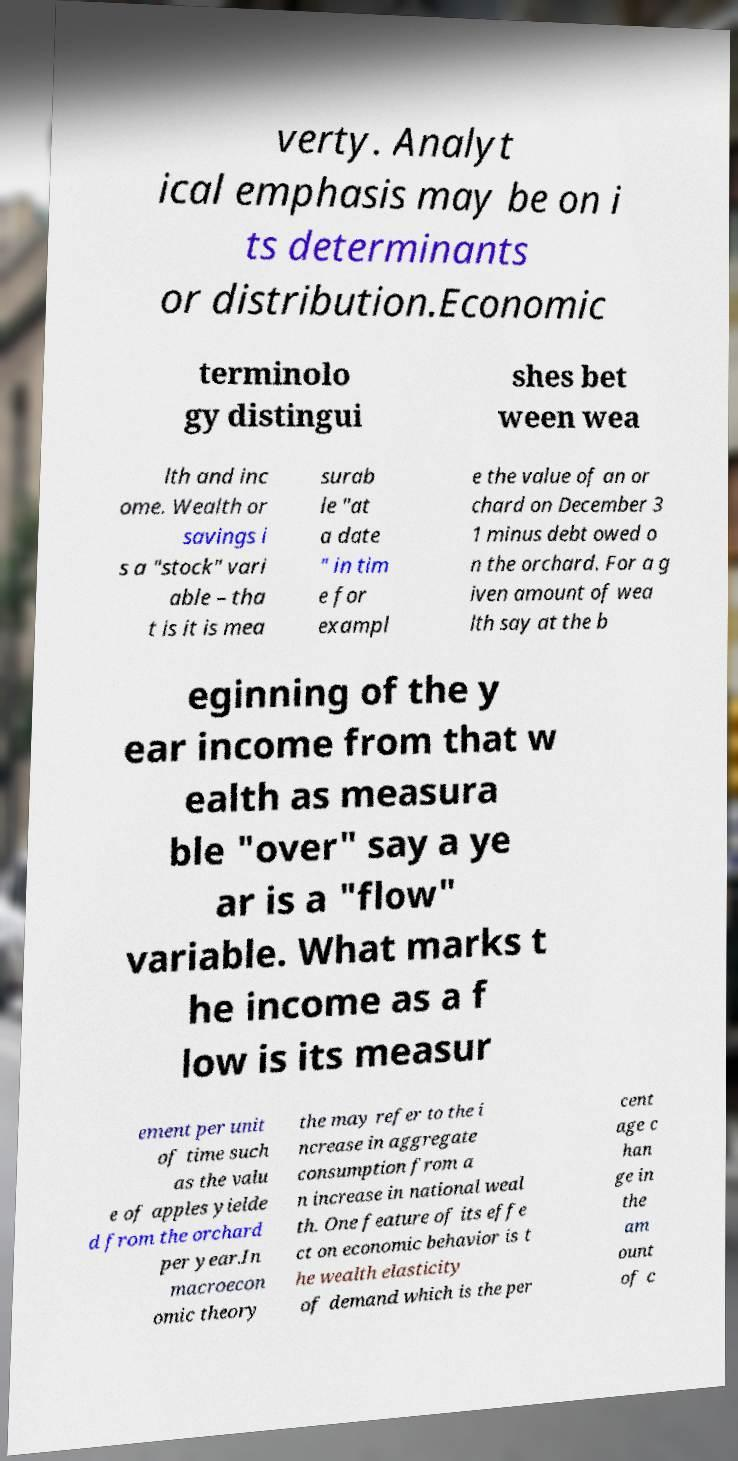Can you read and provide the text displayed in the image?This photo seems to have some interesting text. Can you extract and type it out for me? verty. Analyt ical emphasis may be on i ts determinants or distribution.Economic terminolo gy distingui shes bet ween wea lth and inc ome. Wealth or savings i s a "stock" vari able – tha t is it is mea surab le "at a date " in tim e for exampl e the value of an or chard on December 3 1 minus debt owed o n the orchard. For a g iven amount of wea lth say at the b eginning of the y ear income from that w ealth as measura ble "over" say a ye ar is a "flow" variable. What marks t he income as a f low is its measur ement per unit of time such as the valu e of apples yielde d from the orchard per year.In macroecon omic theory the may refer to the i ncrease in aggregate consumption from a n increase in national weal th. One feature of its effe ct on economic behavior is t he wealth elasticity of demand which is the per cent age c han ge in the am ount of c 